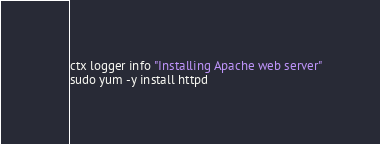Convert code to text. <code><loc_0><loc_0><loc_500><loc_500><_Bash_>
ctx logger info "Installing Apache web server"
sudo yum -y install httpd</code> 